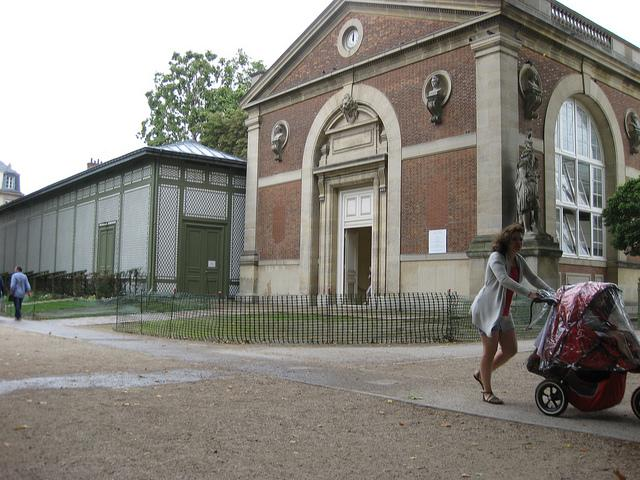What is the woman pushing? Please explain your reasoning. stroller. A woman pushes a buggy down the sidewalk that has a canopy covering it. 